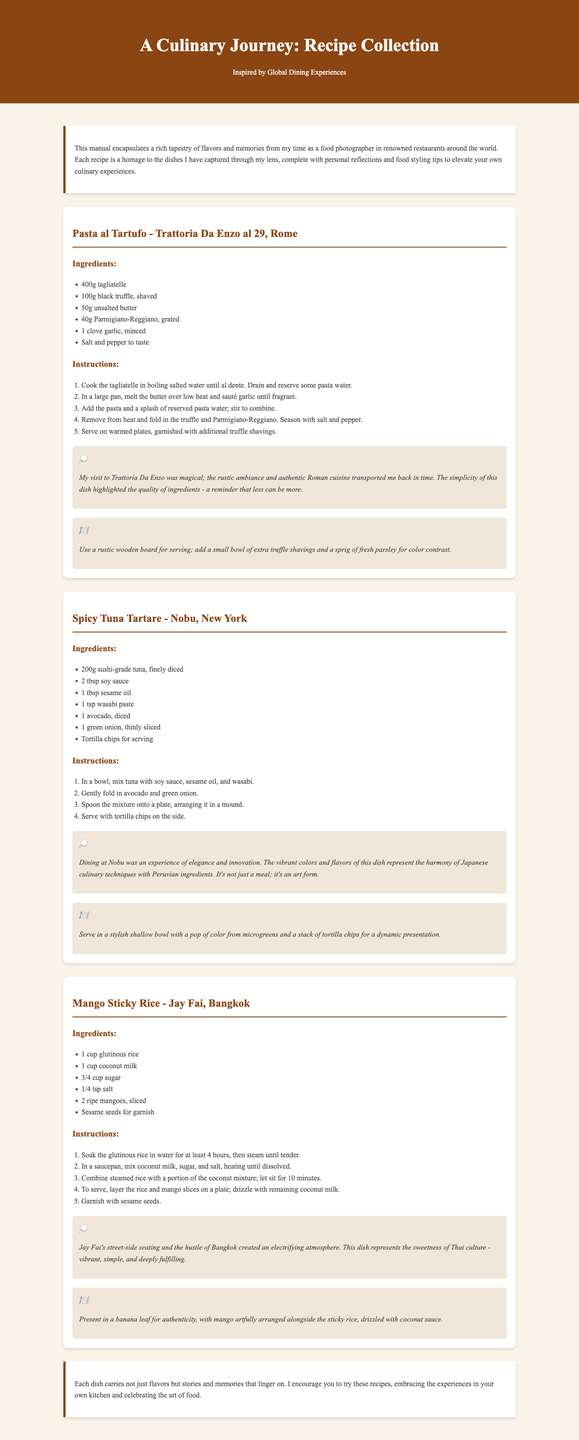What is the title of the document? The title is displayed prominently at the top of the document.
Answer: A Culinary Journey: Recipe Collection How many recipes are included in the document? There are three recipes detailed in the document.
Answer: Three What is the first ingredient listed for Pasta al Tartufo? The first ingredient is found in the ingredients section of the Pasta al Tartufo recipe.
Answer: 400g tagliatelle Which restaurant is associated with the Spicy Tuna Tartare recipe? The restaurant is mentioned directly below the recipe title.
Answer: Nobu What is the preparation time for the Mango Sticky Rice? The document does not explicitly state a preparation time or indicates it can be derived from the instructions.
Answer: Not listed Which city is Trattoria Da Enzo al 29 located in? The city is mentioned in the recipe title.
Answer: Rome What styling tip is provided for Pasta al Tartufo? The styling tip is found in the styling tips section of the Pasta al Tartufo recipe.
Answer: Use a rustic wooden board for serving Which ingredient is specified for garnishing in the Mango Sticky Rice recipe? The ingredient is listed in the ingredients section of the Mango Sticky Rice recipe.
Answer: Sesame seeds What emotion does the reflection for the Spicy Tuna Tartare convey? The reflection discusses an experience that embodies elegance and innovation.
Answer: Elegance 